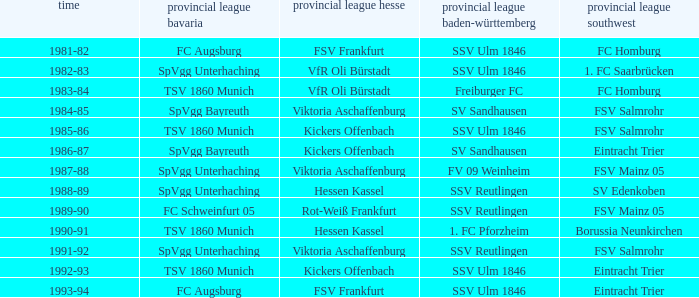Which Oberliga Südwest has an Oberliga Bayern of fc schweinfurt 05? FSV Mainz 05. 